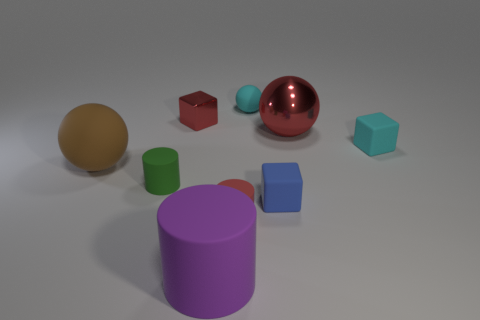Subtract all tiny cyan spheres. How many spheres are left? 2 Add 1 blue cubes. How many objects exist? 10 Subtract all cubes. How many objects are left? 6 Subtract all brown cylinders. Subtract all brown spheres. How many cylinders are left? 3 Subtract all tiny red cylinders. Subtract all small red matte cylinders. How many objects are left? 7 Add 8 tiny red metal blocks. How many tiny red metal blocks are left? 9 Add 9 big yellow rubber things. How many big yellow rubber things exist? 9 Subtract 0 gray cylinders. How many objects are left? 9 